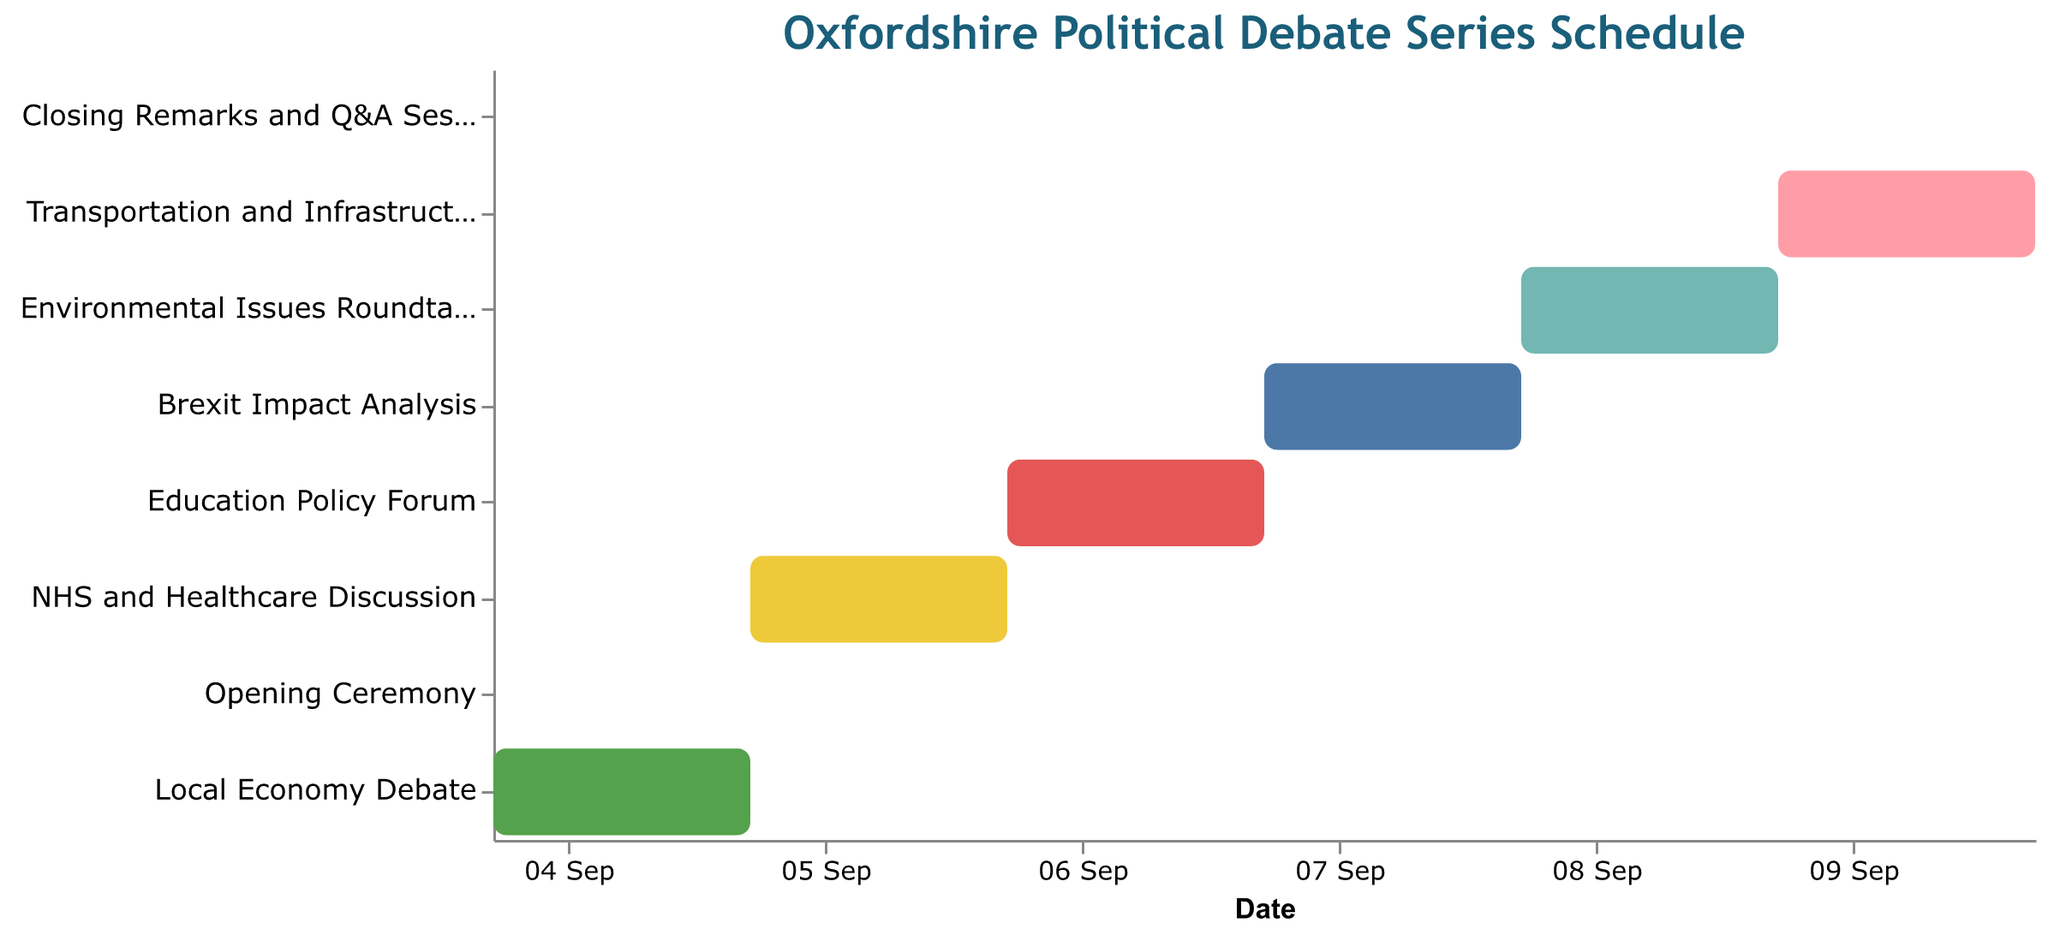Which task marks the start of the debate series? The Gantt Chart shows the task labeled "Opening Ceremony" starting on the first day of the series.
Answer: Opening Ceremony On which days does the Environmental Issues Roundtable take place? The bar corresponding to the "Environmental Issues Roundtable" spans from 8th September to 9th September.
Answer: 8th and 9th September Which task has the shortest duration in the schedule? The "Opening Ceremony" and the "Closing Remarks and Q&A Session" both have bars spanning only one day each, making them the shortest in duration.
Answer: Opening Ceremony, Closing Remarks and Q&A Session What is the duration of the Transportation and Infrastructure Debate? The bar for the "Transportation and Infrastructure Debate" spans from 9th September to 10th September, covering 2 days.
Answer: 2 days How many debates or discussions in the schedule last exactly one day? From the chart, "Opening Ceremony" and "Closing Remarks and Q&A Session" each last exactly one day, while the others span over two or more days.
Answer: 2 tasks Which discussion directly follows the Local Economy Debate? The Gantt Chart shows the "NHS and Healthcare Discussion" starting immediately after the end date of the "Local Economy Debate."
Answer: NHS and Healthcare Discussion Arrange the tasks in the order they appear in the series. By following the tasks from the beginning to the end of the chart, the order is: "Opening Ceremony," "Local Economy Debate," "NHS and Healthcare Discussion," "Education Policy Forum," "Brexit Impact Analysis," "Environmental Issues Roundtable," "Transportation and Infrastructure Debate," and "Closing Remarks and Q&A Session."
Answer: Opening Ceremony, Local Economy Debate, NHS and Healthcare Discussion, Education Policy Forum, Brexit Impact Analysis, Environmental Issues Roundtable, Transportation and Infrastructure Debate, Closing Remarks and Q&A Session How many tasks are there in the schedule? The Gantt Chart features an individual bar for each task, and counting these bars results in a total of 8 tasks.
Answer: 8 tasks 